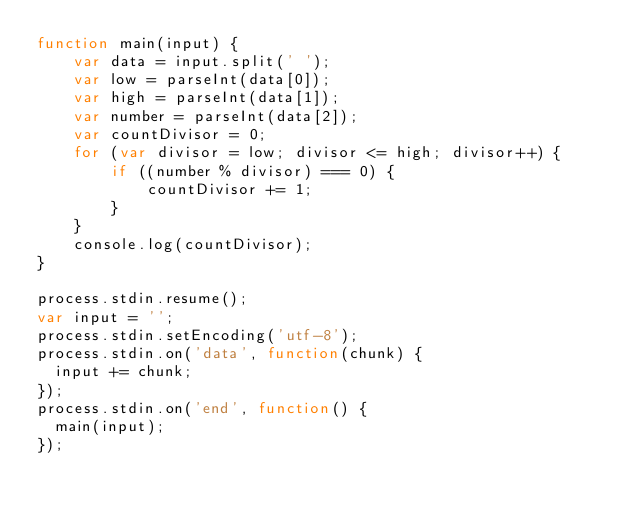Convert code to text. <code><loc_0><loc_0><loc_500><loc_500><_JavaScript_>function main(input) {
    var data = input.split(' ');
    var low = parseInt(data[0]);
    var high = parseInt(data[1]);
    var number = parseInt(data[2]);
    var countDivisor = 0;
    for (var divisor = low; divisor <= high; divisor++) {
        if ((number % divisor) === 0) {
            countDivisor += 1;
        }
    }
    console.log(countDivisor);
}

process.stdin.resume();
var input = '';  
process.stdin.setEncoding('utf-8');
process.stdin.on('data', function(chunk) {
  input += chunk;
});
process.stdin.on('end', function() {
  main(input);
});</code> 